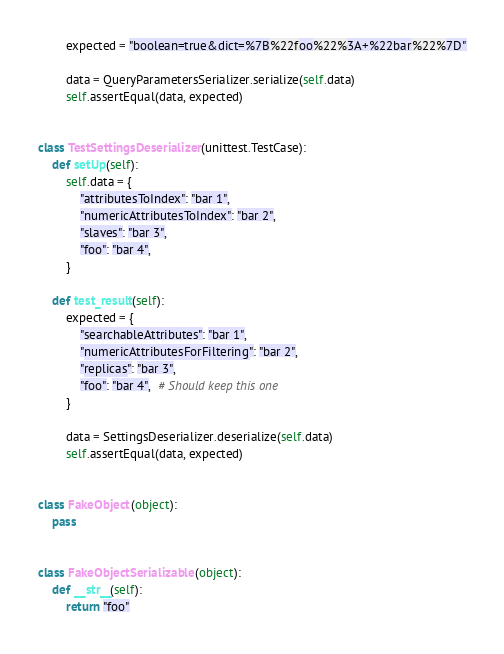<code> <loc_0><loc_0><loc_500><loc_500><_Python_>        expected = "boolean=true&dict=%7B%22foo%22%3A+%22bar%22%7D"

        data = QueryParametersSerializer.serialize(self.data)
        self.assertEqual(data, expected)


class TestSettingsDeserializer(unittest.TestCase):
    def setUp(self):
        self.data = {
            "attributesToIndex": "bar 1",
            "numericAttributesToIndex": "bar 2",
            "slaves": "bar 3",
            "foo": "bar 4",
        }

    def test_result(self):
        expected = {
            "searchableAttributes": "bar 1",
            "numericAttributesForFiltering": "bar 2",
            "replicas": "bar 3",
            "foo": "bar 4",  # Should keep this one
        }

        data = SettingsDeserializer.deserialize(self.data)
        self.assertEqual(data, expected)


class FakeObject(object):
    pass


class FakeObjectSerializable(object):
    def __str__(self):
        return "foo"
</code> 